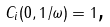Convert formula to latex. <formula><loc_0><loc_0><loc_500><loc_500>C _ { i } ( 0 , 1 / \omega ) = 1 \text {,}</formula> 